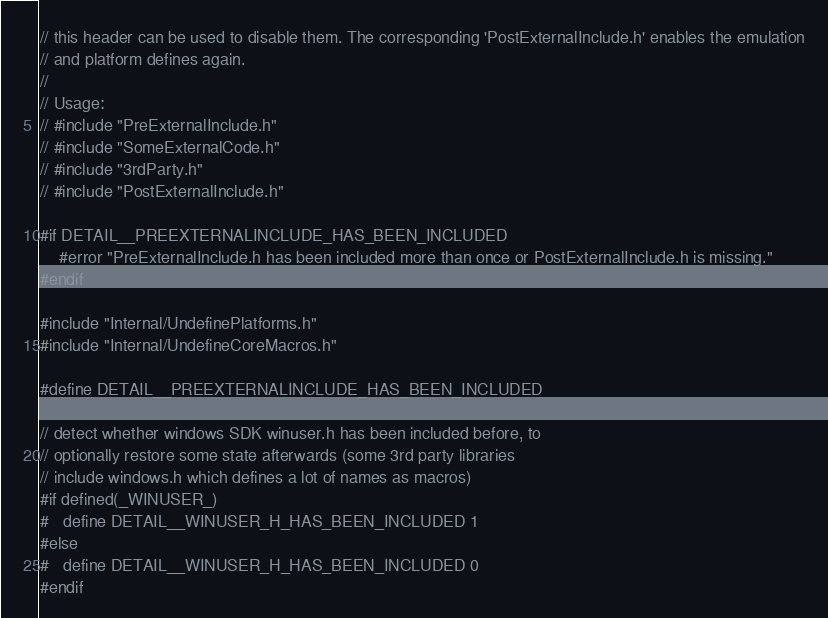<code> <loc_0><loc_0><loc_500><loc_500><_C_>// this header can be used to disable them. The corresponding 'PostExternalInclude.h' enables the emulation
// and platform defines again.
//
// Usage:
// #include "PreExternalInclude.h"
// #include "SomeExternalCode.h"
// #include "3rdParty.h"
// #include "PostExternalInclude.h"

#if DETAIL__PREEXTERNALINCLUDE_HAS_BEEN_INCLUDED
    #error "PreExternalInclude.h has been included more than once or PostExternalInclude.h is missing."
#endif

#include "Internal/UndefinePlatforms.h"
#include "Internal/UndefineCoreMacros.h"

#define DETAIL__PREEXTERNALINCLUDE_HAS_BEEN_INCLUDED

// detect whether windows SDK winuser.h has been included before, to
// optionally restore some state afterwards (some 3rd party libraries
// include windows.h which defines a lot of names as macros)
#if defined(_WINUSER_)
#   define DETAIL__WINUSER_H_HAS_BEEN_INCLUDED 1
#else
#   define DETAIL__WINUSER_H_HAS_BEEN_INCLUDED 0
#endif
</code> 